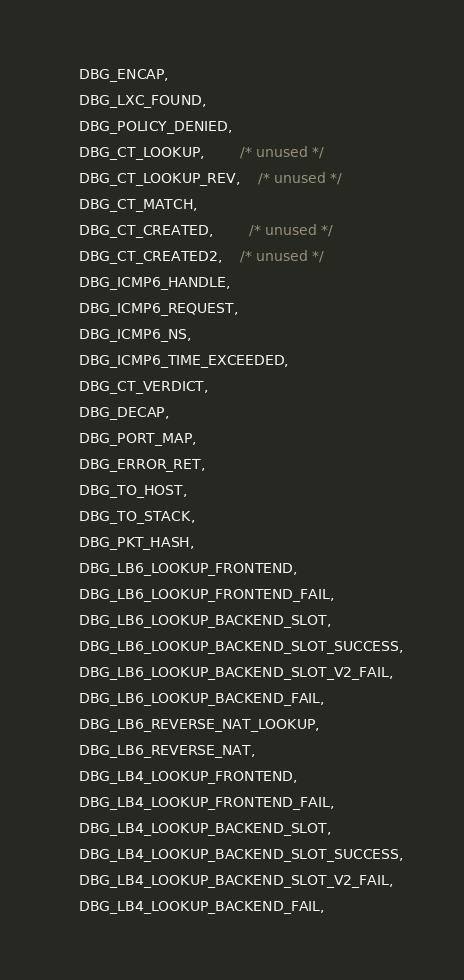<code> <loc_0><loc_0><loc_500><loc_500><_C_>	DBG_ENCAP,
	DBG_LXC_FOUND,
	DBG_POLICY_DENIED,
	DBG_CT_LOOKUP,		/* unused */
	DBG_CT_LOOKUP_REV,	/* unused */
	DBG_CT_MATCH,
	DBG_CT_CREATED,		/* unused */
	DBG_CT_CREATED2,	/* unused */
	DBG_ICMP6_HANDLE,
	DBG_ICMP6_REQUEST,
	DBG_ICMP6_NS,
	DBG_ICMP6_TIME_EXCEEDED,
	DBG_CT_VERDICT,
	DBG_DECAP,
	DBG_PORT_MAP,
	DBG_ERROR_RET,
	DBG_TO_HOST,
	DBG_TO_STACK,
	DBG_PKT_HASH,
	DBG_LB6_LOOKUP_FRONTEND,
	DBG_LB6_LOOKUP_FRONTEND_FAIL,
	DBG_LB6_LOOKUP_BACKEND_SLOT,
	DBG_LB6_LOOKUP_BACKEND_SLOT_SUCCESS,
	DBG_LB6_LOOKUP_BACKEND_SLOT_V2_FAIL,
	DBG_LB6_LOOKUP_BACKEND_FAIL,
	DBG_LB6_REVERSE_NAT_LOOKUP,
	DBG_LB6_REVERSE_NAT,
	DBG_LB4_LOOKUP_FRONTEND,
	DBG_LB4_LOOKUP_FRONTEND_FAIL,
	DBG_LB4_LOOKUP_BACKEND_SLOT,
	DBG_LB4_LOOKUP_BACKEND_SLOT_SUCCESS,
	DBG_LB4_LOOKUP_BACKEND_SLOT_V2_FAIL,
	DBG_LB4_LOOKUP_BACKEND_FAIL,</code> 